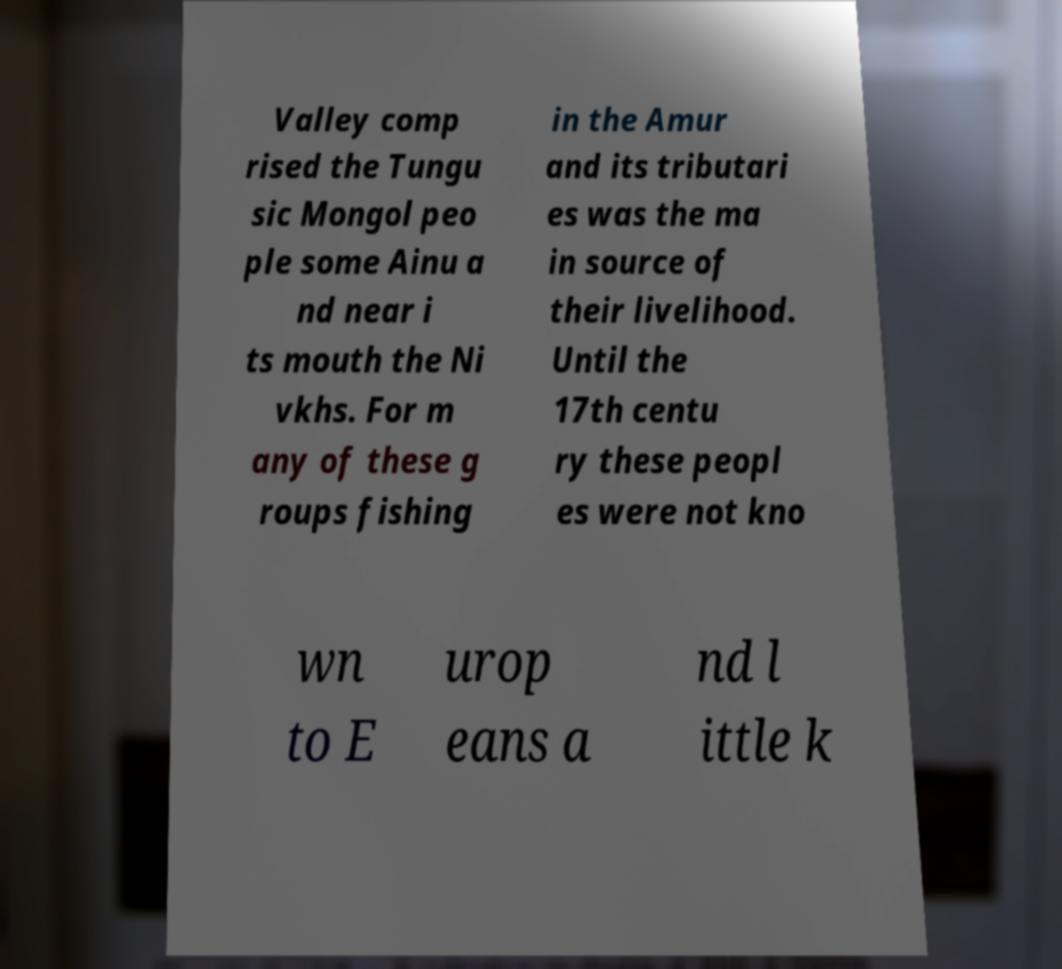I need the written content from this picture converted into text. Can you do that? Valley comp rised the Tungu sic Mongol peo ple some Ainu a nd near i ts mouth the Ni vkhs. For m any of these g roups fishing in the Amur and its tributari es was the ma in source of their livelihood. Until the 17th centu ry these peopl es were not kno wn to E urop eans a nd l ittle k 